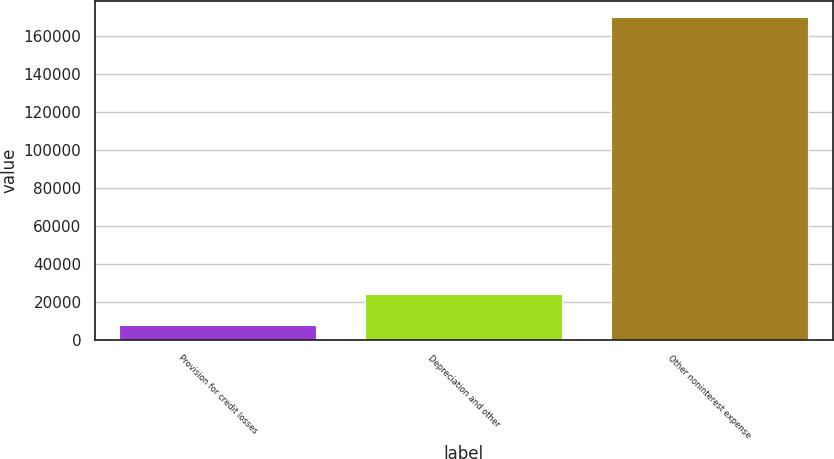Convert chart. <chart><loc_0><loc_0><loc_500><loc_500><bar_chart><fcel>Provision for credit losses<fcel>Depreciation and other<fcel>Other noninterest expense<nl><fcel>8003<fcel>24171.5<fcel>169688<nl></chart> 